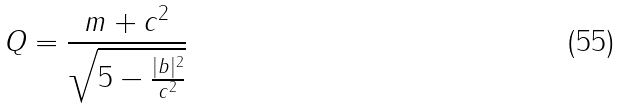<formula> <loc_0><loc_0><loc_500><loc_500>Q = \frac { m + c ^ { 2 } } { \sqrt { 5 - \frac { | b | ^ { 2 } } { c ^ { 2 } } } }</formula> 